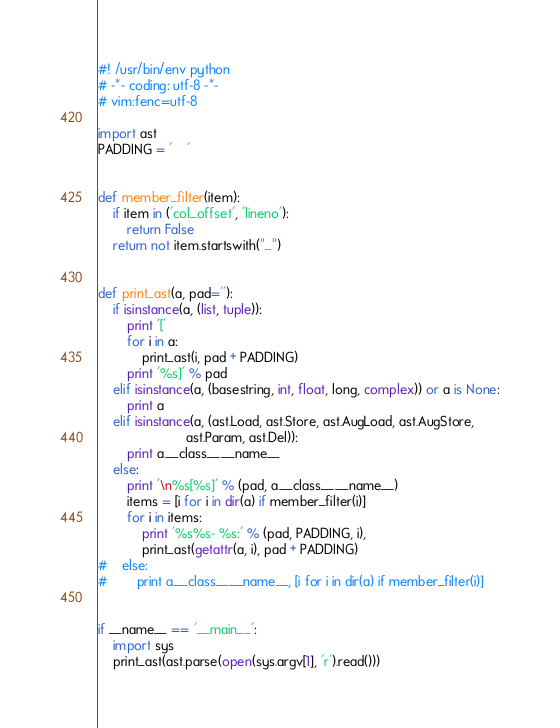<code> <loc_0><loc_0><loc_500><loc_500><_Python_>#! /usr/bin/env python
# -*- coding: utf-8 -*-
# vim:fenc=utf-8

import ast
PADDING = '    '


def member_filter(item):
    if item in ('col_offset', 'lineno'):
        return False
    return not item.startswith("_")


def print_ast(a, pad=''):
    if isinstance(a, (list, tuple)):
        print '['
        for i in a:
            print_ast(i, pad + PADDING)
        print '%s]' % pad
    elif isinstance(a, (basestring, int, float, long, complex)) or a is None:
        print a
    elif isinstance(a, (ast.Load, ast.Store, ast.AugLoad, ast.AugStore,
                        ast.Param, ast.Del)):
        print a.__class__.__name__
    else:
        print '\n%s[%s]' % (pad, a.__class__.__name__)
        items = [i for i in dir(a) if member_filter(i)]
        for i in items:
            print '%s%s- %s:' % (pad, PADDING, i),
            print_ast(getattr(a, i), pad + PADDING)
#    else:
#        print a.__class__.__name__, [i for i in dir(a) if member_filter(i)]


if __name__ == '__main__':
    import sys
    print_ast(ast.parse(open(sys.argv[1], 'r').read()))
</code> 